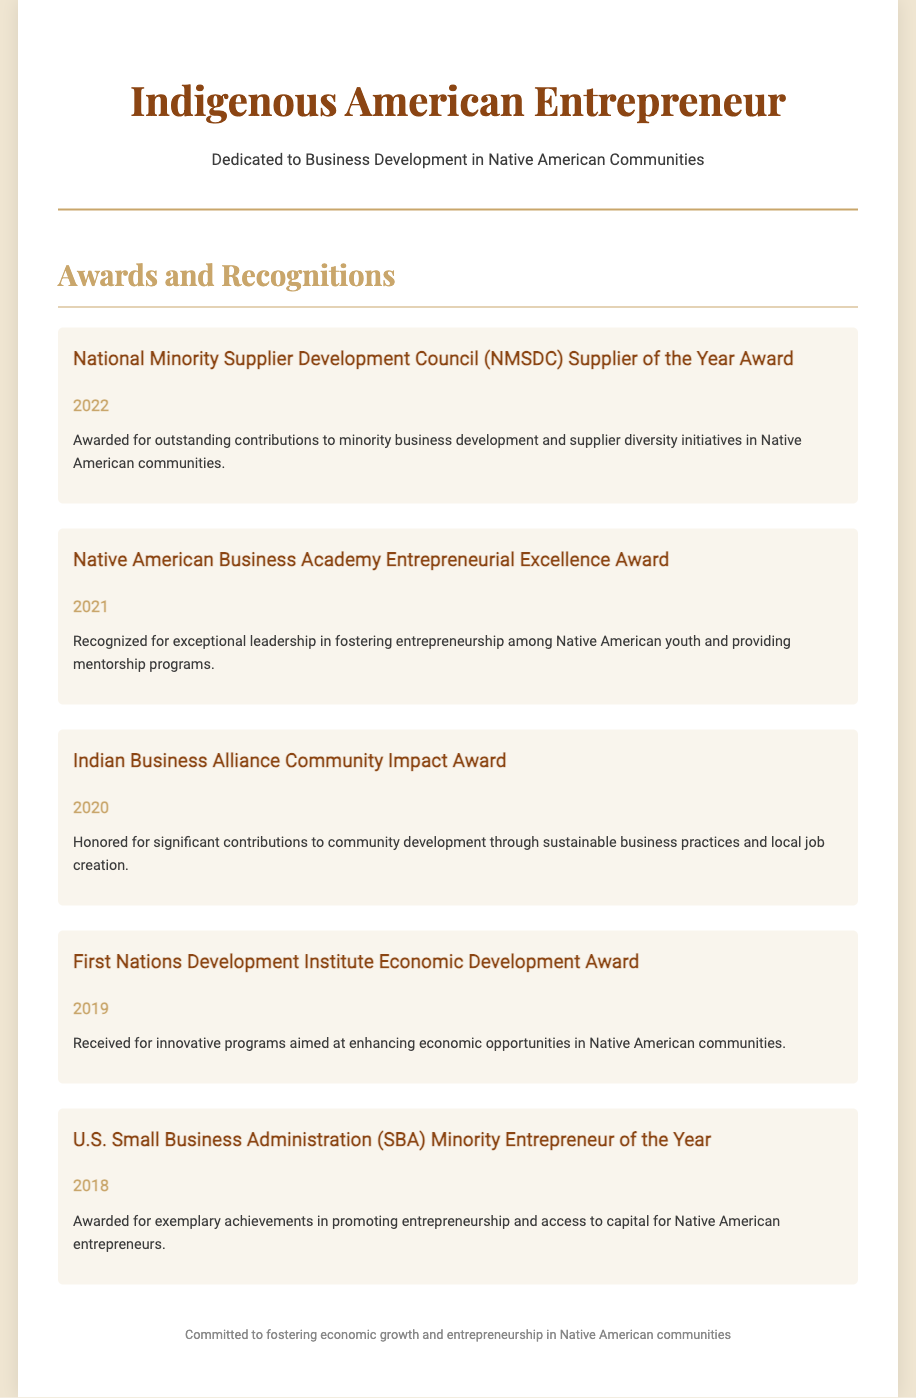What award did you receive in 2022? The 2022 award mentioned is the National Minority Supplier Development Council (NMSDC) Supplier of the Year Award.
Answer: National Minority Supplier Development Council (NMSDC) Supplier of the Year Award In which year did you receive the Entrepreneurial Excellence Award? The Entrepreneurial Excellence Award was received in 2021.
Answer: 2021 What organization awarded you the Community Impact Award? The award is given by the Indian Business Alliance.
Answer: Indian Business Alliance How many awards are listed in the Curriculum Vitae? There are a total of five awards listed in the document.
Answer: 5 What achievement was recognized in 2018? The award received in 2018 recognizes exemplary achievements in promoting entrepreneurship and access to capital for Native American entrepreneurs.
Answer: U.S. Small Business Administration (SBA) Minority Entrepreneur of the Year What was the focus of the award received in 2019? The 2019 award focused on enhancing economic opportunities in Native American communities.
Answer: Economic Development Award Which award recognized leadership in fostering entrepreneurship among Native American youth? The award for fostering entrepreneurship among Native American youth is the Native American Business Academy Entrepreneurial Excellence Award.
Answer: Native American Business Academy Entrepreneurial Excellence Award What is the theme of the awards received? The overall theme centers around contributions to Native American entrepreneurship and community development.
Answer: Contributions to Native American entrepreneurship and community development 